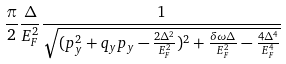<formula> <loc_0><loc_0><loc_500><loc_500>\frac { \pi } { 2 } \frac { \Delta } { E _ { F } ^ { 2 } } \frac { 1 } { \sqrt { ( p _ { y } ^ { 2 } + q _ { y } p _ { y } - \frac { 2 \Delta ^ { 2 } } { E _ { F } ^ { 2 } } ) ^ { 2 } + \frac { \delta \omega \Delta } { E _ { F } ^ { 2 } } - \frac { 4 \Delta ^ { 4 } } { E _ { F } ^ { 4 } } } }</formula> 